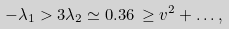<formula> <loc_0><loc_0><loc_500><loc_500>- \lambda _ { 1 } > 3 \lambda _ { 2 } \simeq 0 . 3 6 \, \geq v ^ { 2 } + \dots ,</formula> 